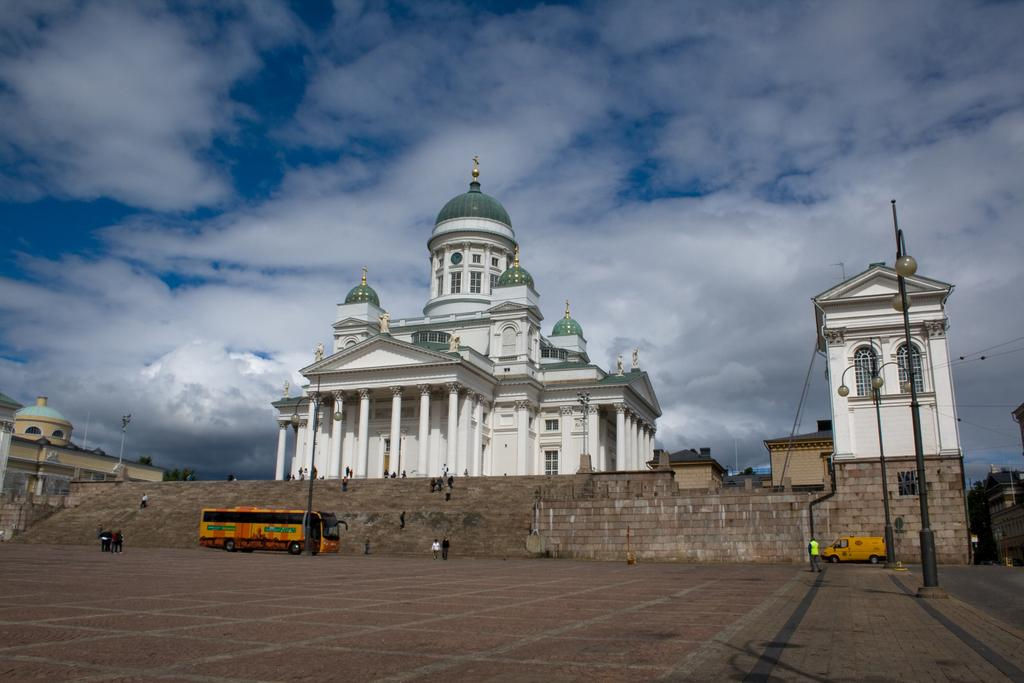What type of structures can be seen in the image? There are buildings in the image. What features can be observed on the buildings? The buildings have windows. What other objects are present in the image? There are light poles, stairs, a wall, wires, people, and vehicles on the road in the image. What can be seen in the sky? The sky is visible in the image. How many types of structures are present in the image? There are buildings, light poles, stairs, a wall, and wires, which makes a total of five types of structures. Can you tell me how many judges are present in the image? There are no judges present in the image. What type of ocean can be seen in the image? There is no ocean present in the image. 